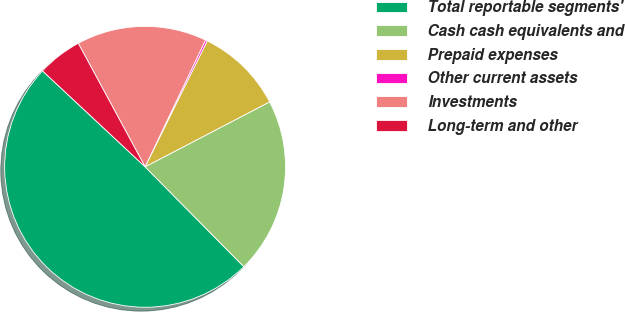Convert chart. <chart><loc_0><loc_0><loc_500><loc_500><pie_chart><fcel>Total reportable segments'<fcel>Cash cash equivalents and<fcel>Prepaid expenses<fcel>Other current assets<fcel>Investments<fcel>Long-term and other<nl><fcel>49.37%<fcel>20.24%<fcel>10.05%<fcel>0.22%<fcel>14.97%<fcel>5.14%<nl></chart> 